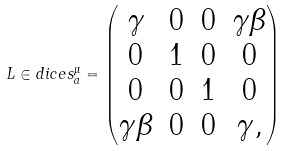Convert formula to latex. <formula><loc_0><loc_0><loc_500><loc_500>L \in d i c e s { ^ { \mu } _ { a } } = \begin{pmatrix} \gamma & 0 & 0 & \gamma \beta \\ 0 & 1 & 0 & 0 \\ 0 & 0 & 1 & 0 \\ \gamma \beta & 0 & 0 & \gamma , \end{pmatrix}</formula> 